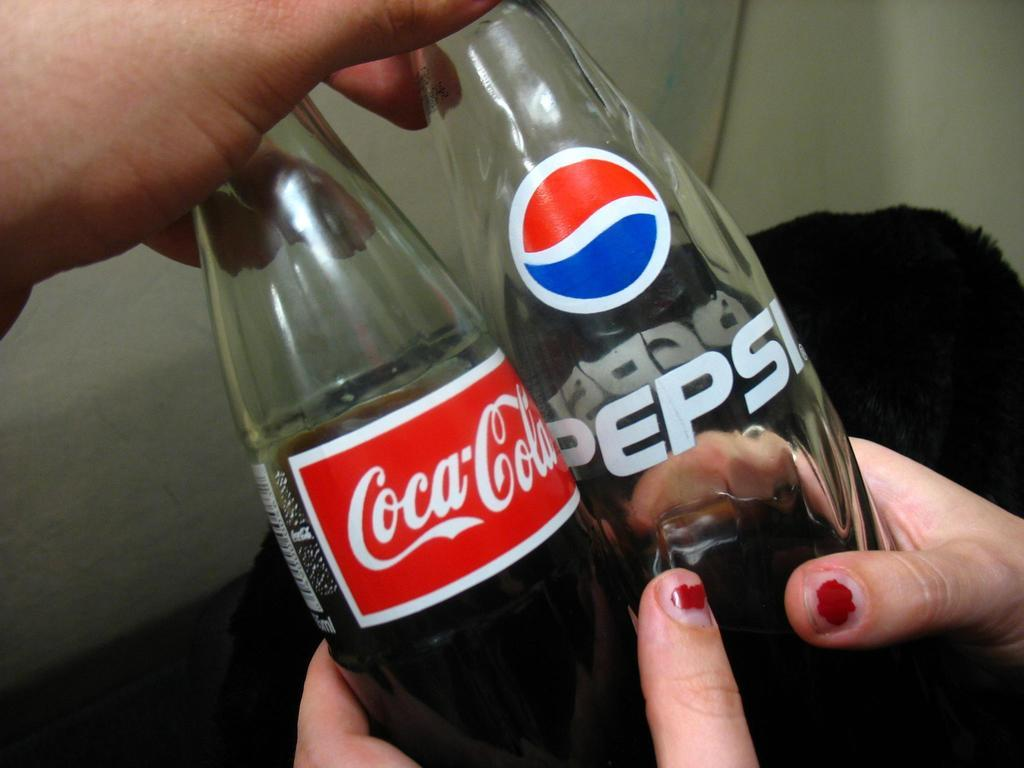What type of beverage bottles are present in the image? There is a Coca-Cola bottle and a Pepsi bottle in the image. What type of fog can be seen in the image? There is no fog present in the image; it only features Coca-Cola and Pepsi bottles. Is there a picture of a home in the image? There is no picture of a home in the image; it only features Coca-Cola and Pepsi bottles. 